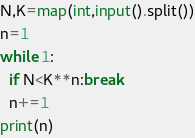Convert code to text. <code><loc_0><loc_0><loc_500><loc_500><_Python_>N,K=map(int,input().split())
n=1
while 1:
  if N<K**n:break
  n+=1
print(n)</code> 